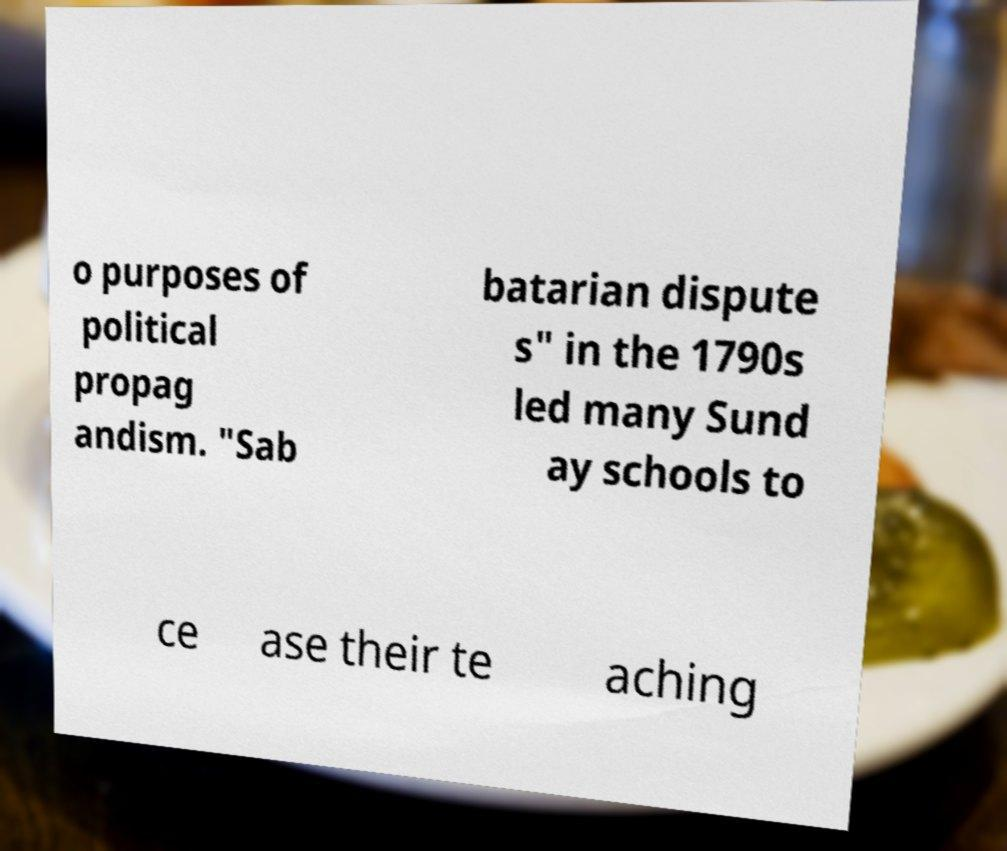Could you extract and type out the text from this image? o purposes of political propag andism. "Sab batarian dispute s" in the 1790s led many Sund ay schools to ce ase their te aching 